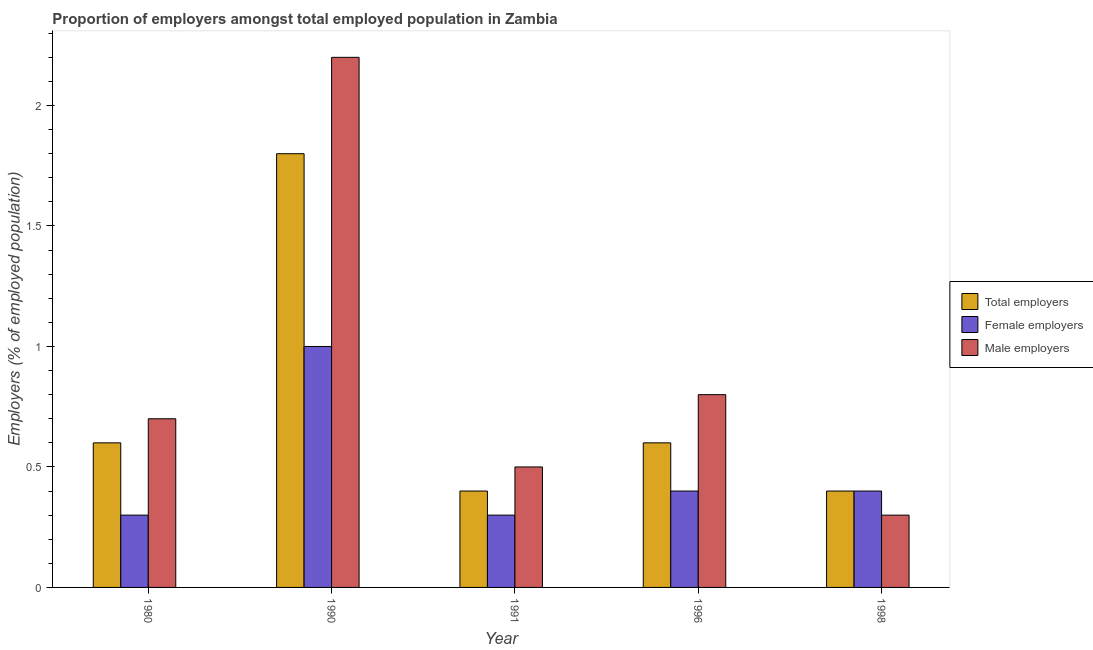How many different coloured bars are there?
Provide a succinct answer. 3. How many groups of bars are there?
Your answer should be very brief. 5. How many bars are there on the 4th tick from the left?
Keep it short and to the point. 3. What is the label of the 1st group of bars from the left?
Make the answer very short. 1980. In how many cases, is the number of bars for a given year not equal to the number of legend labels?
Provide a short and direct response. 0. What is the percentage of male employers in 1990?
Your response must be concise. 2.2. Across all years, what is the maximum percentage of male employers?
Keep it short and to the point. 2.2. Across all years, what is the minimum percentage of male employers?
Ensure brevity in your answer.  0.3. What is the total percentage of male employers in the graph?
Your response must be concise. 4.5. What is the difference between the percentage of female employers in 1980 and that in 1996?
Provide a succinct answer. -0.1. What is the difference between the percentage of female employers in 1980 and the percentage of total employers in 1996?
Your answer should be compact. -0.1. What is the average percentage of female employers per year?
Keep it short and to the point. 0.48. In the year 1998, what is the difference between the percentage of male employers and percentage of female employers?
Keep it short and to the point. 0. In how many years, is the percentage of total employers greater than 1.8 %?
Make the answer very short. 0. What is the ratio of the percentage of female employers in 1990 to that in 1998?
Give a very brief answer. 2.5. Is the percentage of male employers in 1980 less than that in 1990?
Keep it short and to the point. Yes. Is the difference between the percentage of female employers in 1980 and 1991 greater than the difference between the percentage of total employers in 1980 and 1991?
Ensure brevity in your answer.  No. What is the difference between the highest and the second highest percentage of male employers?
Keep it short and to the point. 1.4. What is the difference between the highest and the lowest percentage of male employers?
Keep it short and to the point. 1.9. In how many years, is the percentage of male employers greater than the average percentage of male employers taken over all years?
Give a very brief answer. 1. What does the 3rd bar from the left in 1980 represents?
Ensure brevity in your answer.  Male employers. What does the 2nd bar from the right in 1980 represents?
Offer a very short reply. Female employers. Are all the bars in the graph horizontal?
Offer a very short reply. No. What is the difference between two consecutive major ticks on the Y-axis?
Offer a very short reply. 0.5. Are the values on the major ticks of Y-axis written in scientific E-notation?
Provide a succinct answer. No. Where does the legend appear in the graph?
Provide a short and direct response. Center right. What is the title of the graph?
Provide a short and direct response. Proportion of employers amongst total employed population in Zambia. What is the label or title of the X-axis?
Your answer should be very brief. Year. What is the label or title of the Y-axis?
Provide a short and direct response. Employers (% of employed population). What is the Employers (% of employed population) in Total employers in 1980?
Provide a short and direct response. 0.6. What is the Employers (% of employed population) in Female employers in 1980?
Provide a short and direct response. 0.3. What is the Employers (% of employed population) of Male employers in 1980?
Provide a succinct answer. 0.7. What is the Employers (% of employed population) in Total employers in 1990?
Your answer should be very brief. 1.8. What is the Employers (% of employed population) in Male employers in 1990?
Your answer should be compact. 2.2. What is the Employers (% of employed population) of Total employers in 1991?
Your answer should be compact. 0.4. What is the Employers (% of employed population) of Female employers in 1991?
Offer a terse response. 0.3. What is the Employers (% of employed population) in Total employers in 1996?
Make the answer very short. 0.6. What is the Employers (% of employed population) of Female employers in 1996?
Keep it short and to the point. 0.4. What is the Employers (% of employed population) in Male employers in 1996?
Give a very brief answer. 0.8. What is the Employers (% of employed population) of Total employers in 1998?
Offer a very short reply. 0.4. What is the Employers (% of employed population) in Female employers in 1998?
Keep it short and to the point. 0.4. What is the Employers (% of employed population) in Male employers in 1998?
Provide a short and direct response. 0.3. Across all years, what is the maximum Employers (% of employed population) of Total employers?
Provide a succinct answer. 1.8. Across all years, what is the maximum Employers (% of employed population) in Female employers?
Ensure brevity in your answer.  1. Across all years, what is the maximum Employers (% of employed population) of Male employers?
Offer a terse response. 2.2. Across all years, what is the minimum Employers (% of employed population) in Total employers?
Your answer should be compact. 0.4. Across all years, what is the minimum Employers (% of employed population) of Female employers?
Provide a short and direct response. 0.3. Across all years, what is the minimum Employers (% of employed population) in Male employers?
Give a very brief answer. 0.3. What is the total Employers (% of employed population) of Total employers in the graph?
Give a very brief answer. 3.8. What is the total Employers (% of employed population) in Male employers in the graph?
Make the answer very short. 4.5. What is the difference between the Employers (% of employed population) of Total employers in 1980 and that in 1990?
Offer a terse response. -1.2. What is the difference between the Employers (% of employed population) of Female employers in 1980 and that in 1990?
Offer a very short reply. -0.7. What is the difference between the Employers (% of employed population) in Male employers in 1980 and that in 1991?
Keep it short and to the point. 0.2. What is the difference between the Employers (% of employed population) in Total employers in 1980 and that in 1996?
Ensure brevity in your answer.  0. What is the difference between the Employers (% of employed population) in Female employers in 1980 and that in 1996?
Provide a succinct answer. -0.1. What is the difference between the Employers (% of employed population) in Female employers in 1980 and that in 1998?
Keep it short and to the point. -0.1. What is the difference between the Employers (% of employed population) of Total employers in 1990 and that in 1991?
Provide a succinct answer. 1.4. What is the difference between the Employers (% of employed population) of Male employers in 1990 and that in 1991?
Keep it short and to the point. 1.7. What is the difference between the Employers (% of employed population) of Female employers in 1990 and that in 1996?
Provide a short and direct response. 0.6. What is the difference between the Employers (% of employed population) in Total employers in 1990 and that in 1998?
Offer a terse response. 1.4. What is the difference between the Employers (% of employed population) in Female employers in 1991 and that in 1996?
Your response must be concise. -0.1. What is the difference between the Employers (% of employed population) of Male employers in 1991 and that in 1996?
Keep it short and to the point. -0.3. What is the difference between the Employers (% of employed population) in Female employers in 1991 and that in 1998?
Make the answer very short. -0.1. What is the difference between the Employers (% of employed population) in Female employers in 1996 and that in 1998?
Offer a terse response. 0. What is the difference between the Employers (% of employed population) of Female employers in 1980 and the Employers (% of employed population) of Male employers in 1990?
Provide a short and direct response. -1.9. What is the difference between the Employers (% of employed population) in Total employers in 1980 and the Employers (% of employed population) in Male employers in 1991?
Keep it short and to the point. 0.1. What is the difference between the Employers (% of employed population) of Female employers in 1980 and the Employers (% of employed population) of Male employers in 1991?
Provide a succinct answer. -0.2. What is the difference between the Employers (% of employed population) of Total employers in 1980 and the Employers (% of employed population) of Female employers in 1996?
Ensure brevity in your answer.  0.2. What is the difference between the Employers (% of employed population) of Female employers in 1980 and the Employers (% of employed population) of Male employers in 1996?
Your answer should be compact. -0.5. What is the difference between the Employers (% of employed population) of Total employers in 1980 and the Employers (% of employed population) of Female employers in 1998?
Your response must be concise. 0.2. What is the difference between the Employers (% of employed population) of Total employers in 1980 and the Employers (% of employed population) of Male employers in 1998?
Keep it short and to the point. 0.3. What is the difference between the Employers (% of employed population) of Total employers in 1990 and the Employers (% of employed population) of Male employers in 1991?
Give a very brief answer. 1.3. What is the difference between the Employers (% of employed population) in Female employers in 1990 and the Employers (% of employed population) in Male employers in 1991?
Offer a very short reply. 0.5. What is the difference between the Employers (% of employed population) in Total employers in 1990 and the Employers (% of employed population) in Female employers in 1996?
Offer a terse response. 1.4. What is the difference between the Employers (% of employed population) of Female employers in 1990 and the Employers (% of employed population) of Male employers in 1996?
Keep it short and to the point. 0.2. What is the difference between the Employers (% of employed population) in Total employers in 1990 and the Employers (% of employed population) in Female employers in 1998?
Keep it short and to the point. 1.4. What is the difference between the Employers (% of employed population) of Female employers in 1990 and the Employers (% of employed population) of Male employers in 1998?
Provide a succinct answer. 0.7. What is the difference between the Employers (% of employed population) of Total employers in 1991 and the Employers (% of employed population) of Male employers in 1996?
Keep it short and to the point. -0.4. What is the difference between the Employers (% of employed population) in Total employers in 1991 and the Employers (% of employed population) in Male employers in 1998?
Ensure brevity in your answer.  0.1. What is the difference between the Employers (% of employed population) of Total employers in 1996 and the Employers (% of employed population) of Female employers in 1998?
Keep it short and to the point. 0.2. What is the difference between the Employers (% of employed population) of Total employers in 1996 and the Employers (% of employed population) of Male employers in 1998?
Your answer should be compact. 0.3. What is the average Employers (% of employed population) in Total employers per year?
Your answer should be compact. 0.76. What is the average Employers (% of employed population) in Female employers per year?
Offer a very short reply. 0.48. In the year 1980, what is the difference between the Employers (% of employed population) of Total employers and Employers (% of employed population) of Female employers?
Keep it short and to the point. 0.3. In the year 1990, what is the difference between the Employers (% of employed population) of Total employers and Employers (% of employed population) of Male employers?
Offer a terse response. -0.4. In the year 1990, what is the difference between the Employers (% of employed population) of Female employers and Employers (% of employed population) of Male employers?
Offer a terse response. -1.2. In the year 1991, what is the difference between the Employers (% of employed population) of Total employers and Employers (% of employed population) of Male employers?
Ensure brevity in your answer.  -0.1. In the year 1996, what is the difference between the Employers (% of employed population) in Total employers and Employers (% of employed population) in Male employers?
Your response must be concise. -0.2. In the year 1998, what is the difference between the Employers (% of employed population) of Total employers and Employers (% of employed population) of Female employers?
Your answer should be compact. 0. In the year 1998, what is the difference between the Employers (% of employed population) of Female employers and Employers (% of employed population) of Male employers?
Give a very brief answer. 0.1. What is the ratio of the Employers (% of employed population) in Total employers in 1980 to that in 1990?
Provide a succinct answer. 0.33. What is the ratio of the Employers (% of employed population) in Female employers in 1980 to that in 1990?
Your response must be concise. 0.3. What is the ratio of the Employers (% of employed population) of Male employers in 1980 to that in 1990?
Give a very brief answer. 0.32. What is the ratio of the Employers (% of employed population) in Total employers in 1980 to that in 1991?
Give a very brief answer. 1.5. What is the ratio of the Employers (% of employed population) in Total employers in 1980 to that in 1996?
Provide a succinct answer. 1. What is the ratio of the Employers (% of employed population) of Male employers in 1980 to that in 1996?
Keep it short and to the point. 0.88. What is the ratio of the Employers (% of employed population) in Female employers in 1980 to that in 1998?
Keep it short and to the point. 0.75. What is the ratio of the Employers (% of employed population) in Male employers in 1980 to that in 1998?
Provide a succinct answer. 2.33. What is the ratio of the Employers (% of employed population) of Female employers in 1990 to that in 1991?
Your answer should be very brief. 3.33. What is the ratio of the Employers (% of employed population) of Male employers in 1990 to that in 1991?
Give a very brief answer. 4.4. What is the ratio of the Employers (% of employed population) of Female employers in 1990 to that in 1996?
Your response must be concise. 2.5. What is the ratio of the Employers (% of employed population) in Male employers in 1990 to that in 1996?
Give a very brief answer. 2.75. What is the ratio of the Employers (% of employed population) of Total employers in 1990 to that in 1998?
Offer a terse response. 4.5. What is the ratio of the Employers (% of employed population) in Female employers in 1990 to that in 1998?
Give a very brief answer. 2.5. What is the ratio of the Employers (% of employed population) of Male employers in 1990 to that in 1998?
Provide a short and direct response. 7.33. What is the ratio of the Employers (% of employed population) of Total employers in 1991 to that in 1996?
Provide a short and direct response. 0.67. What is the ratio of the Employers (% of employed population) of Male employers in 1991 to that in 1998?
Ensure brevity in your answer.  1.67. What is the ratio of the Employers (% of employed population) in Male employers in 1996 to that in 1998?
Offer a very short reply. 2.67. What is the difference between the highest and the second highest Employers (% of employed population) in Female employers?
Provide a short and direct response. 0.6. What is the difference between the highest and the second highest Employers (% of employed population) of Male employers?
Give a very brief answer. 1.4. 